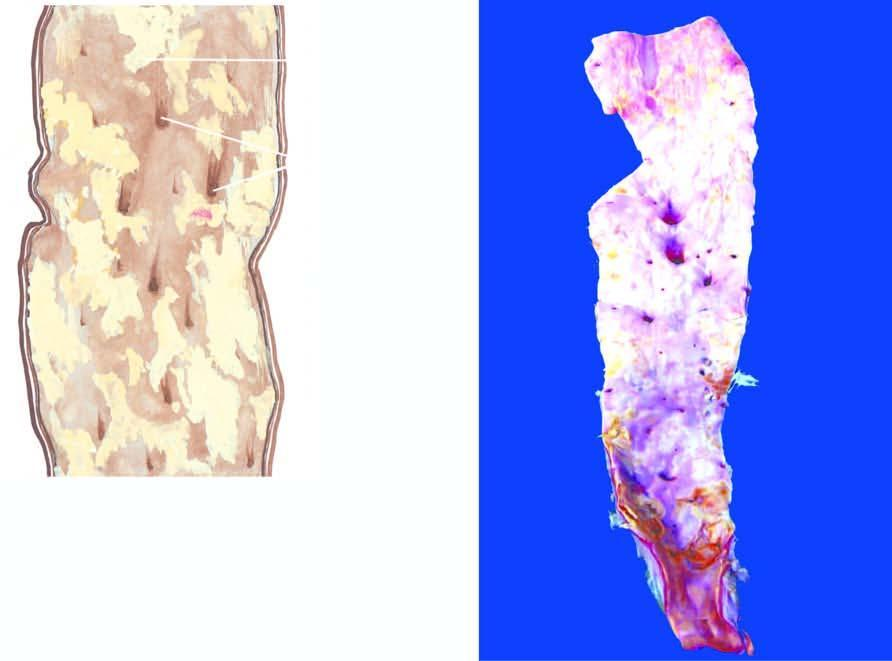re the inner circle shown with green line raised yellowish-white lesions raised above the surface?
Answer the question using a single word or phrase. No 